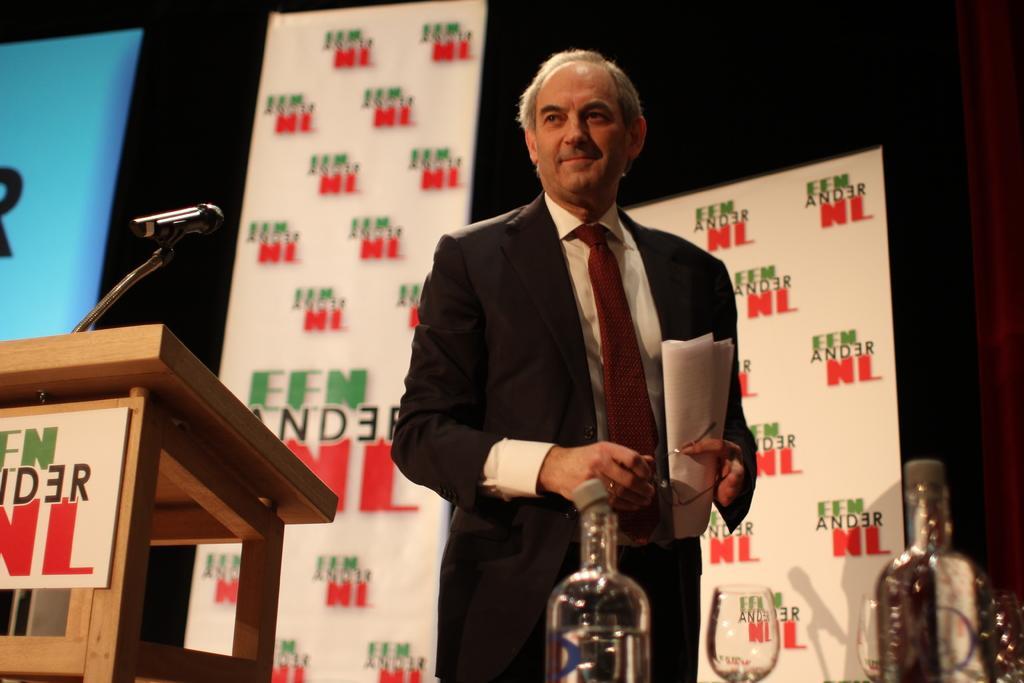How would you summarize this image in a sentence or two? This is a picture of a person wearing a black jacket holding his spectacles in his hand and standing on the stage and opposite to him there is table on which two bottles and a glass and beside there is a wooden desk on which there is a mike on it. 